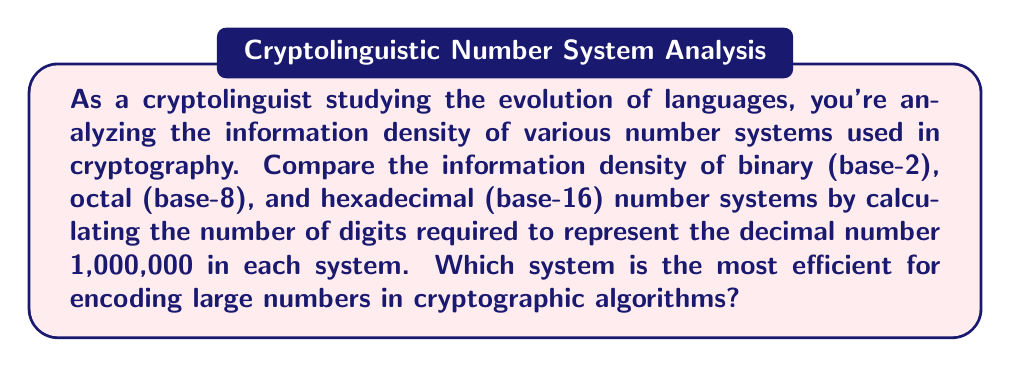Give your solution to this math problem. To solve this problem, we need to convert the decimal number 1,000,000 to binary, octal, and hexadecimal systems, then compare the number of digits required for each representation.

1. Binary (base-2) conversion:
   $1,000,000_{10} = 11110100001001000000_2$
   To convert to binary, we divide by 2 repeatedly and keep track of the remainders:
   $$\begin{align}
   1,000,000 \div 2 &= 500,000 \text{ remainder } 0 \\
   500,000 \div 2 &= 250,000 \text{ remainder } 0 \\
   &\vdots \\
   1 \div 2 &= 0 \text{ remainder } 1
   \end{align}$$
   Reading the remainders from bottom to top gives us the binary representation.
   Number of digits: 20

2. Octal (base-8) conversion:
   $1,000,000_{10} = 3641100_8$
   To convert to octal, we divide by 8 repeatedly:
   $$\begin{align}
   1,000,000 \div 8 &= 125,000 \text{ remainder } 0 \\
   125,000 \div 8 &= 15,625 \text{ remainder } 0 \\
   &\vdots \\
   3 \div 8 &= 0 \text{ remainder } 3
   \end{align}$$
   Number of digits: 7

3. Hexadecimal (base-16) conversion:
   $1,000,000_{10} = F4240_{16}$
   To convert to hexadecimal, we divide by 16 repeatedly:
   $$\begin{align}
   1,000,000 \div 16 &= 62,500 \text{ remainder } 0 \\
   62,500 \div 16 &= 3,906 \text{ remainder } 4 \\
   &\vdots \\
   15 \div 16 &= 0 \text{ remainder } 15 \text{ (F)}
   \end{align}$$
   Number of digits: 5

Comparing the number of digits required:
- Binary: 20 digits
- Octal: 7 digits
- Hexadecimal: 5 digits

The hexadecimal system requires the least number of digits to represent 1,000,000, making it the most efficient for encoding large numbers in cryptographic algorithms.
Answer: Hexadecimal (base-16) is the most efficient system for encoding large numbers in cryptographic algorithms, requiring only 5 digits to represent 1,000,000, compared to 7 digits in octal and 20 digits in binary. 